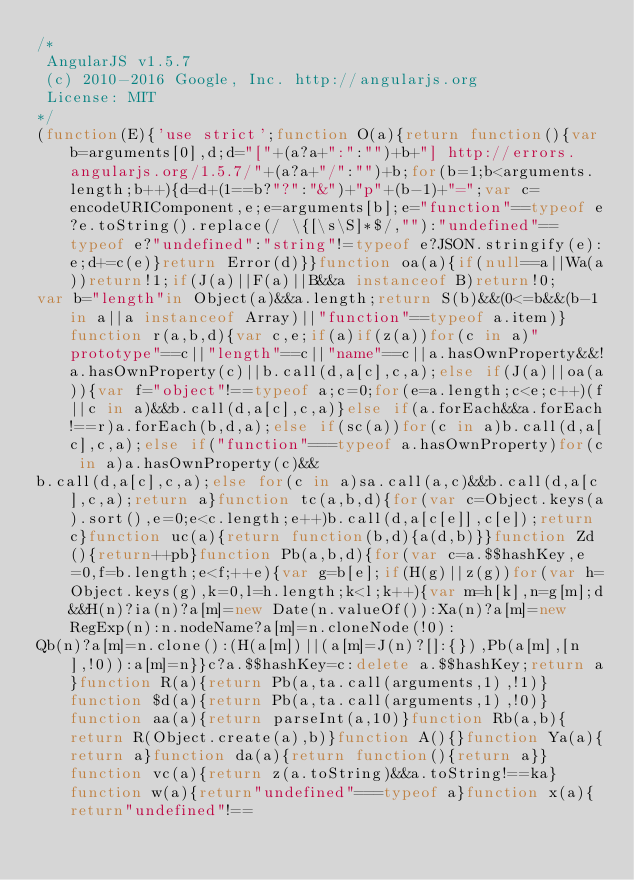Convert code to text. <code><loc_0><loc_0><loc_500><loc_500><_JavaScript_>/*
 AngularJS v1.5.7
 (c) 2010-2016 Google, Inc. http://angularjs.org
 License: MIT
*/
(function(E){'use strict';function O(a){return function(){var b=arguments[0],d;d="["+(a?a+":":"")+b+"] http://errors.angularjs.org/1.5.7/"+(a?a+"/":"")+b;for(b=1;b<arguments.length;b++){d=d+(1==b?"?":"&")+"p"+(b-1)+"=";var c=encodeURIComponent,e;e=arguments[b];e="function"==typeof e?e.toString().replace(/ \{[\s\S]*$/,""):"undefined"==typeof e?"undefined":"string"!=typeof e?JSON.stringify(e):e;d+=c(e)}return Error(d)}}function oa(a){if(null==a||Wa(a))return!1;if(J(a)||F(a)||B&&a instanceof B)return!0;
var b="length"in Object(a)&&a.length;return S(b)&&(0<=b&&(b-1 in a||a instanceof Array)||"function"==typeof a.item)}function r(a,b,d){var c,e;if(a)if(z(a))for(c in a)"prototype"==c||"length"==c||"name"==c||a.hasOwnProperty&&!a.hasOwnProperty(c)||b.call(d,a[c],c,a);else if(J(a)||oa(a)){var f="object"!==typeof a;c=0;for(e=a.length;c<e;c++)(f||c in a)&&b.call(d,a[c],c,a)}else if(a.forEach&&a.forEach!==r)a.forEach(b,d,a);else if(sc(a))for(c in a)b.call(d,a[c],c,a);else if("function"===typeof a.hasOwnProperty)for(c in a)a.hasOwnProperty(c)&&
b.call(d,a[c],c,a);else for(c in a)sa.call(a,c)&&b.call(d,a[c],c,a);return a}function tc(a,b,d){for(var c=Object.keys(a).sort(),e=0;e<c.length;e++)b.call(d,a[c[e]],c[e]);return c}function uc(a){return function(b,d){a(d,b)}}function Zd(){return++pb}function Pb(a,b,d){for(var c=a.$$hashKey,e=0,f=b.length;e<f;++e){var g=b[e];if(H(g)||z(g))for(var h=Object.keys(g),k=0,l=h.length;k<l;k++){var m=h[k],n=g[m];d&&H(n)?ia(n)?a[m]=new Date(n.valueOf()):Xa(n)?a[m]=new RegExp(n):n.nodeName?a[m]=n.cloneNode(!0):
Qb(n)?a[m]=n.clone():(H(a[m])||(a[m]=J(n)?[]:{}),Pb(a[m],[n],!0)):a[m]=n}}c?a.$$hashKey=c:delete a.$$hashKey;return a}function R(a){return Pb(a,ta.call(arguments,1),!1)}function $d(a){return Pb(a,ta.call(arguments,1),!0)}function aa(a){return parseInt(a,10)}function Rb(a,b){return R(Object.create(a),b)}function A(){}function Ya(a){return a}function da(a){return function(){return a}}function vc(a){return z(a.toString)&&a.toString!==ka}function w(a){return"undefined"===typeof a}function x(a){return"undefined"!==</code> 